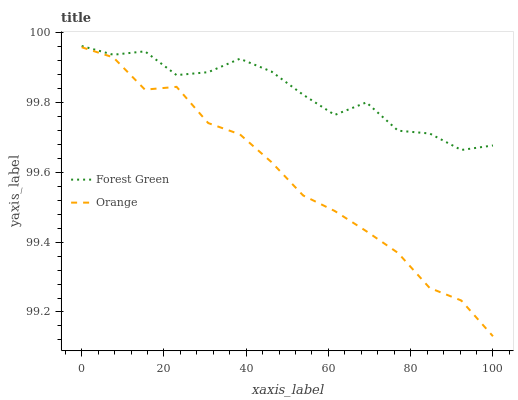Does Orange have the minimum area under the curve?
Answer yes or no. Yes. Does Forest Green have the maximum area under the curve?
Answer yes or no. Yes. Does Forest Green have the minimum area under the curve?
Answer yes or no. No. Is Orange the smoothest?
Answer yes or no. Yes. Is Forest Green the roughest?
Answer yes or no. Yes. Is Forest Green the smoothest?
Answer yes or no. No. Does Orange have the lowest value?
Answer yes or no. Yes. Does Forest Green have the lowest value?
Answer yes or no. No. Does Forest Green have the highest value?
Answer yes or no. Yes. Is Orange less than Forest Green?
Answer yes or no. Yes. Is Forest Green greater than Orange?
Answer yes or no. Yes. Does Orange intersect Forest Green?
Answer yes or no. No. 